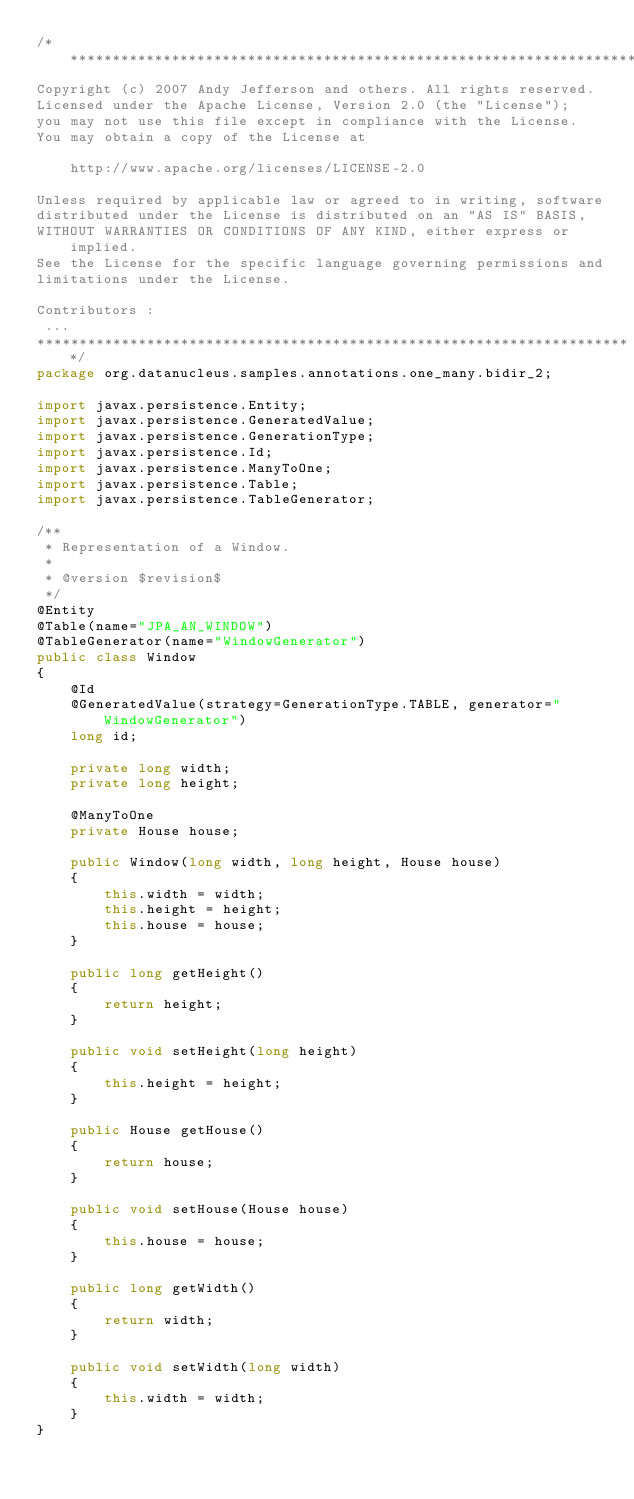Convert code to text. <code><loc_0><loc_0><loc_500><loc_500><_Java_>/**********************************************************************
Copyright (c) 2007 Andy Jefferson and others. All rights reserved.
Licensed under the Apache License, Version 2.0 (the "License");
you may not use this file except in compliance with the License.
You may obtain a copy of the License at

    http://www.apache.org/licenses/LICENSE-2.0

Unless required by applicable law or agreed to in writing, software
distributed under the License is distributed on an "AS IS" BASIS,
WITHOUT WARRANTIES OR CONDITIONS OF ANY KIND, either express or implied.
See the License for the specific language governing permissions and
limitations under the License.

Contributors :
 ...
***********************************************************************/
package org.datanucleus.samples.annotations.one_many.bidir_2;

import javax.persistence.Entity;
import javax.persistence.GeneratedValue;
import javax.persistence.GenerationType;
import javax.persistence.Id;
import javax.persistence.ManyToOne;
import javax.persistence.Table;
import javax.persistence.TableGenerator;

/**
 * Representation of a Window.
 *
 * @version $revision$
 */
@Entity
@Table(name="JPA_AN_WINDOW")
@TableGenerator(name="WindowGenerator")
public class Window
{
    @Id
    @GeneratedValue(strategy=GenerationType.TABLE, generator="WindowGenerator")
    long id;

    private long width;
    private long height;

    @ManyToOne
    private House house;

    public Window(long width, long height, House house)
    {
        this.width = width;
        this.height = height;
        this.house = house;
    }

    public long getHeight()
    {
        return height;
    }

    public void setHeight(long height)
    {
        this.height = height;
    }

    public House getHouse()
    {
        return house;
    }

    public void setHouse(House house)
    {
        this.house = house;
    }

    public long getWidth()
    {
        return width;
    }

    public void setWidth(long width)
    {
        this.width = width;
    }
}</code> 